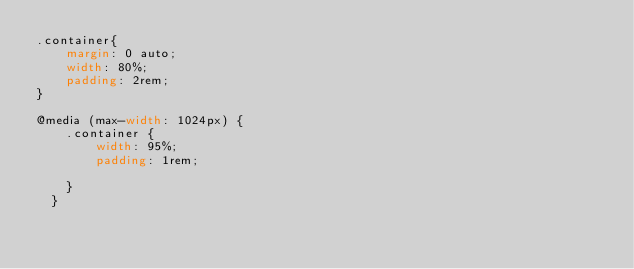Convert code to text. <code><loc_0><loc_0><loc_500><loc_500><_CSS_>.container{
    margin: 0 auto;
    width: 80%;
    padding: 2rem;
}

@media (max-width: 1024px) {
    .container {
        width: 95%;
        padding: 1rem;

    }
  }
  
  </code> 